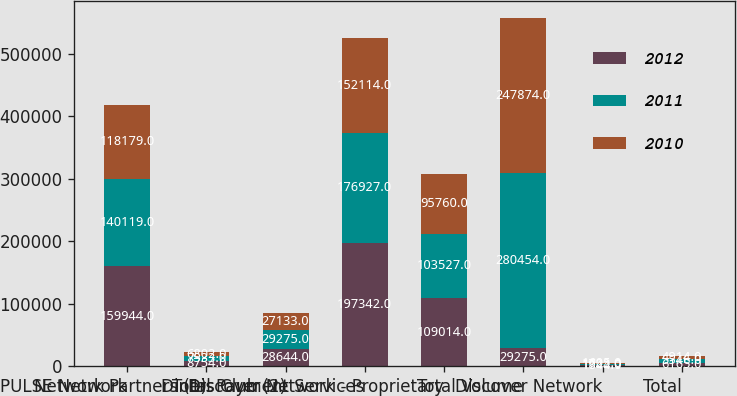Convert chart to OTSL. <chart><loc_0><loc_0><loc_500><loc_500><stacked_bar_chart><ecel><fcel>PULSE Network<fcel>Network Partners (1)<fcel>Diners Club (2)<fcel>Total Payment Services<fcel>Discover Network - Proprietary<fcel>Total Volume<fcel>Discover Network<fcel>Total<nl><fcel>2012<fcel>159944<fcel>8754<fcel>28644<fcel>197342<fcel>109014<fcel>29275<fcel>1844<fcel>6165<nl><fcel>2011<fcel>140119<fcel>7533<fcel>29275<fcel>176927<fcel>103527<fcel>280454<fcel>1722<fcel>5546<nl><fcel>2010<fcel>118179<fcel>6802<fcel>27133<fcel>152114<fcel>95760<fcel>247874<fcel>1605<fcel>4914<nl></chart> 